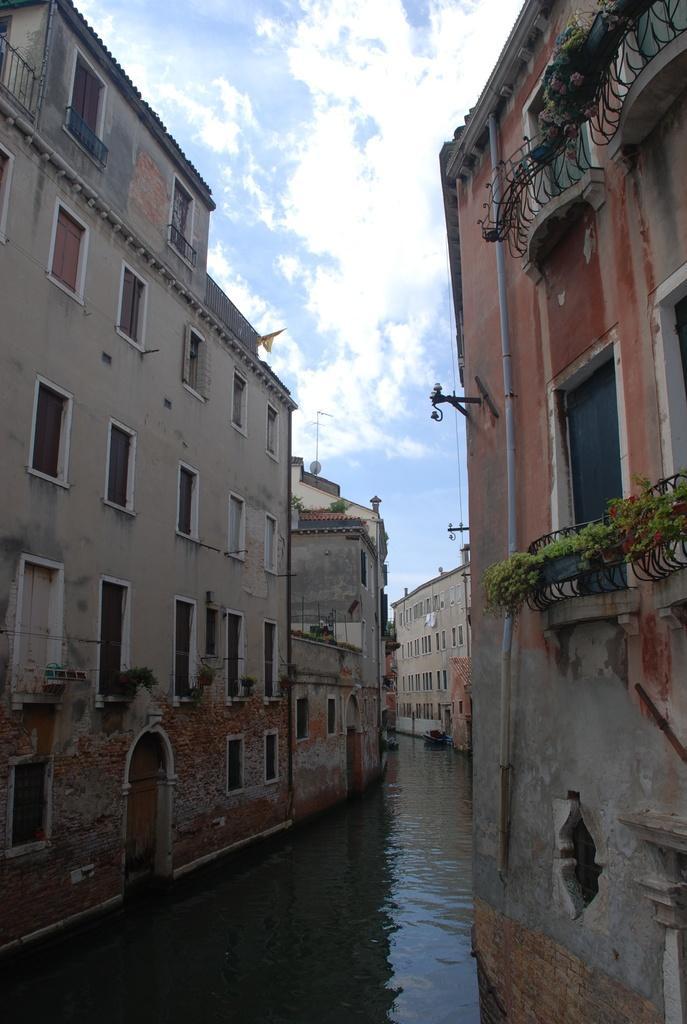Can you describe this image briefly? In this image I can see the water and few buildings on both sides of the water. I can see few plants, few windows and in the background I can see the sky. 